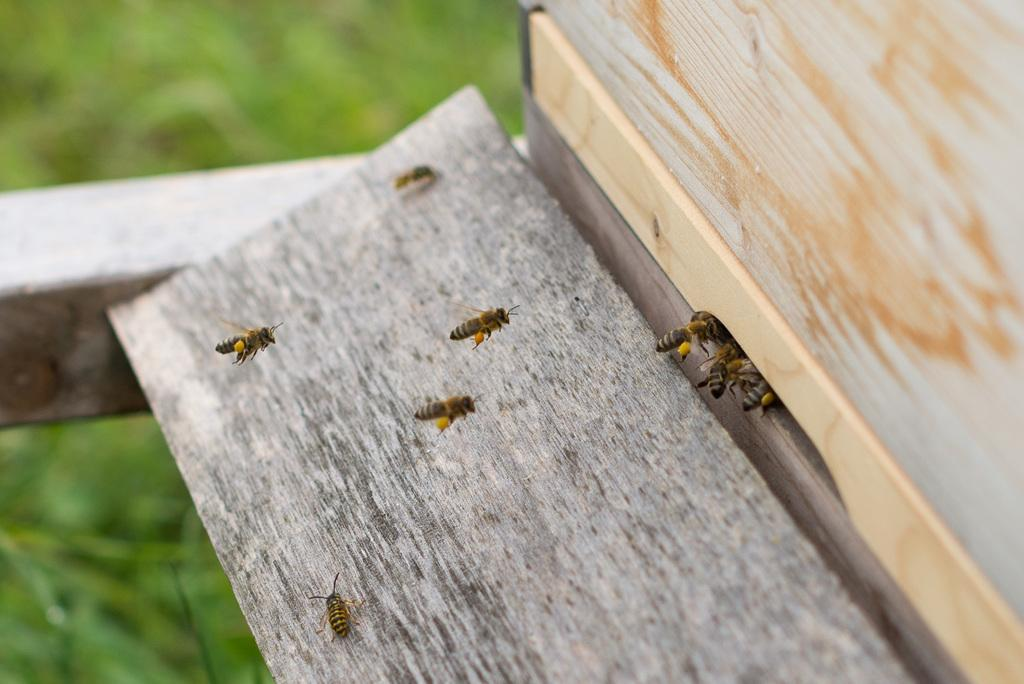What type of animals can be seen in the image? There are bees in the image. What material is the wooden object made of? The wooden object in the image is made of wood. What can be seen in the background of the image? There is greenery visible in the background of the image. What type of cart can be seen on the hill in the image? There is no cart or hill present in the image; it features bees and a wooden object. What type of authority is depicted in the image? There is no authority figure present in the image; it features bees and a wooden object. 